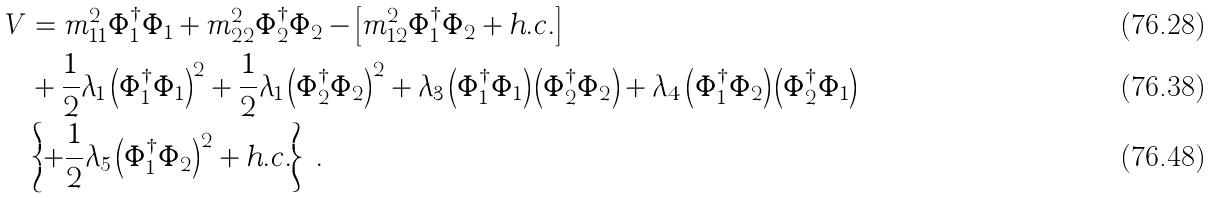<formula> <loc_0><loc_0><loc_500><loc_500>V & = m _ { 1 1 } ^ { 2 } \Phi _ { 1 } ^ { \dagger } \Phi _ { 1 } + m _ { 2 2 } ^ { 2 } \Phi _ { 2 } ^ { \dagger } \Phi _ { 2 } - \left [ m _ { 1 2 } ^ { 2 } \Phi _ { 1 } ^ { \dagger } \Phi _ { 2 } + h . c . \right ] \\ & + \frac { 1 } { 2 } \lambda _ { 1 } \left ( \Phi _ { 1 } ^ { \dagger } \Phi _ { 1 } \right ) ^ { 2 } + \frac { 1 } { 2 } \lambda _ { 1 } \left ( \Phi _ { 2 } ^ { \dagger } \Phi _ { 2 } \right ) ^ { 2 } + \lambda _ { 3 } \left ( \Phi _ { 1 } ^ { \dagger } \Phi _ { 1 } \right ) \left ( \Phi _ { 2 } ^ { \dagger } \Phi _ { 2 } \right ) + \lambda _ { 4 } \left ( \Phi _ { 1 } ^ { \dagger } \Phi _ { 2 } \right ) \left ( \Phi _ { 2 } ^ { \dagger } \Phi _ { 1 } \right ) \\ & \left \{ + \frac { 1 } { 2 } \lambda _ { 5 } \left ( \Phi _ { 1 } ^ { \dagger } \Phi _ { 2 } \right ) ^ { 2 } + h . c . \right \} \ .</formula> 